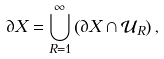Convert formula to latex. <formula><loc_0><loc_0><loc_500><loc_500>\partial X = \bigcup _ { R = 1 } ^ { \infty } \left ( \partial X \cap \mathcal { U } _ { R } \right ) ,</formula> 